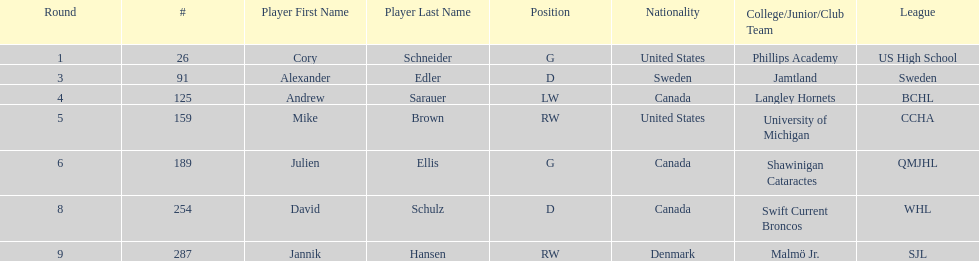Which player was the first player to be drafted? Cory Schneider (G). 